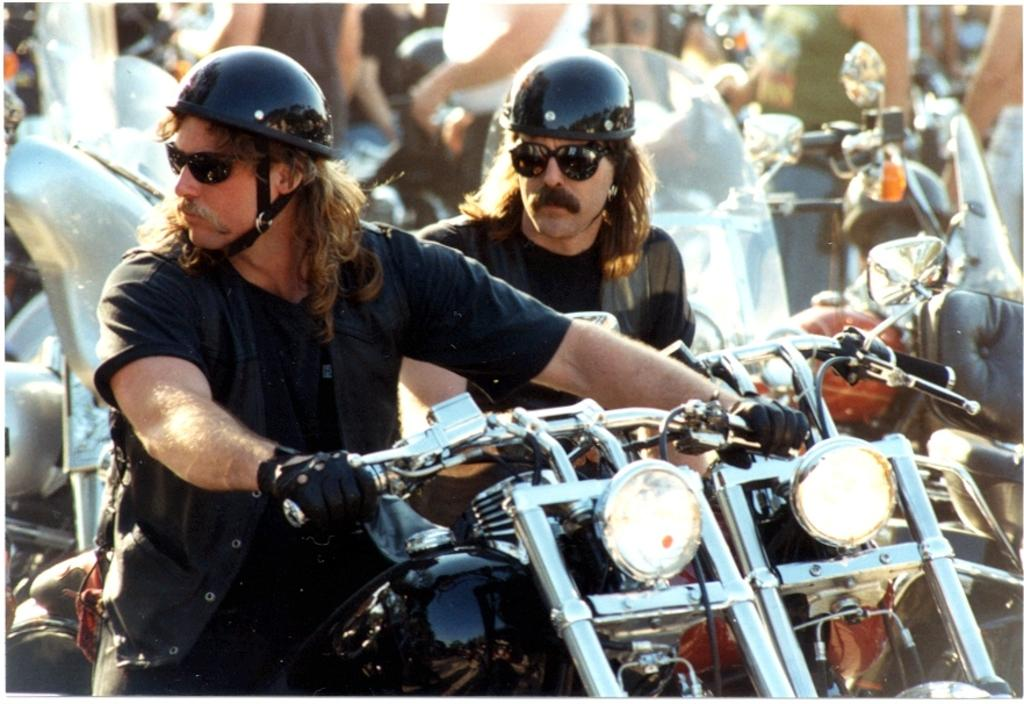How many men are in the image? There are two men in the image. What are the men doing in the image? The men are sitting on bikes. How many bikes are visible in the image? There are multiple bikes in the image. What can be seen in the background of the image? There are people in the background of the image. What type of wine is being served at the event in the image? There is no event or wine present in the image; it features two men sitting on bikes. What color is the gold bike in the image? There is no gold bike present in the image; the bikes are not described as having any specific color. 